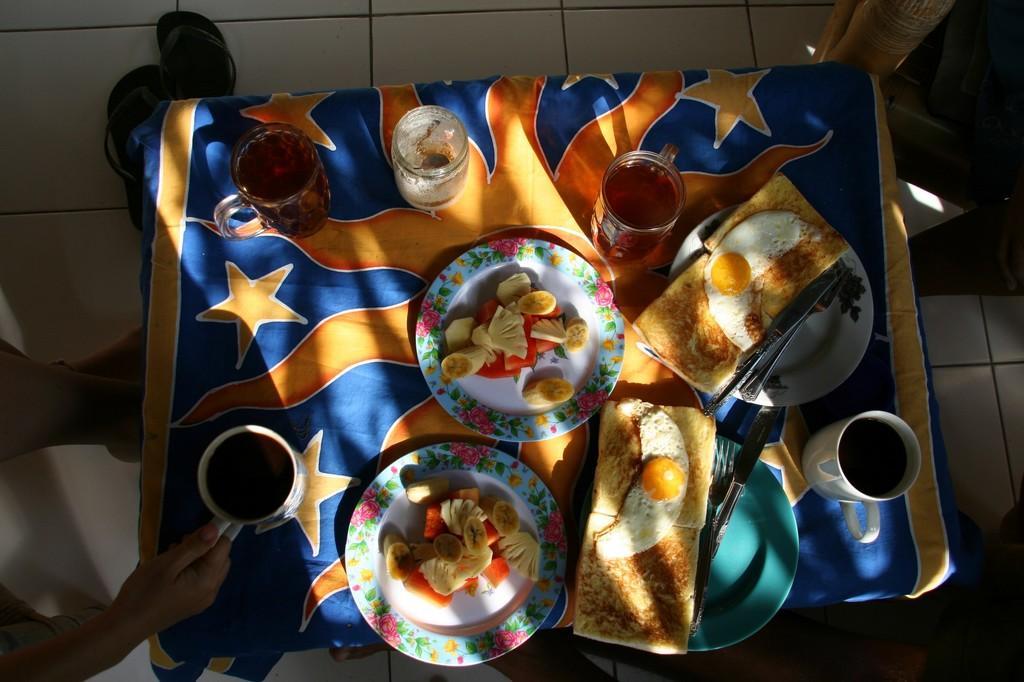Describe this image in one or two sentences. In the picture I can see glasses, food items on plates, knives and some other objects on the table. The table is covered with a cloth. I can also see a person is holding a glass in the hand. On the floor I can see footwear's. 